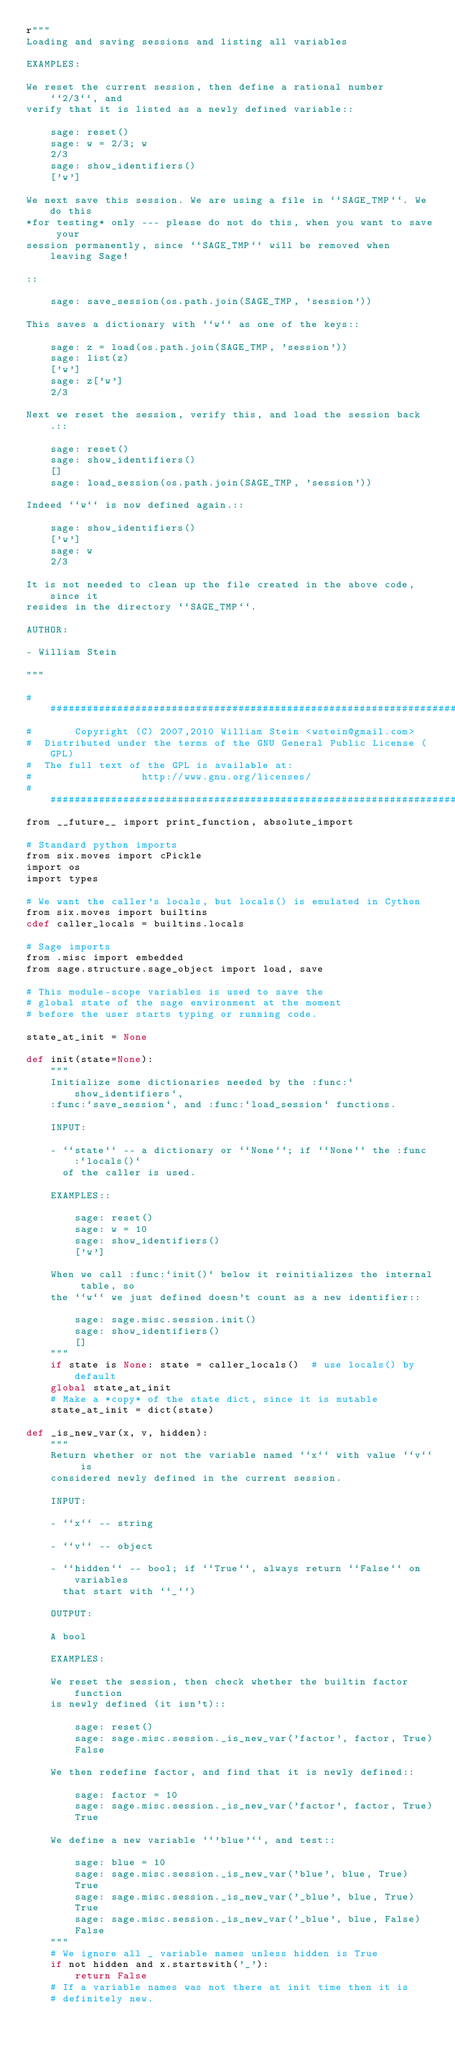Convert code to text. <code><loc_0><loc_0><loc_500><loc_500><_Cython_>r"""
Loading and saving sessions and listing all variables

EXAMPLES:

We reset the current session, then define a rational number ``2/3``, and
verify that it is listed as a newly defined variable::

    sage: reset()
    sage: w = 2/3; w
    2/3
    sage: show_identifiers()
    ['w']

We next save this session. We are using a file in ``SAGE_TMP``. We do this
*for testing* only --- please do not do this, when you want to save your
session permanently, since ``SAGE_TMP`` will be removed when leaving Sage!

::

    sage: save_session(os.path.join(SAGE_TMP, 'session'))

This saves a dictionary with ``w`` as one of the keys::

    sage: z = load(os.path.join(SAGE_TMP, 'session'))
    sage: list(z)
    ['w']
    sage: z['w']
    2/3

Next we reset the session, verify this, and load the session back.::

    sage: reset()
    sage: show_identifiers()
    []
    sage: load_session(os.path.join(SAGE_TMP, 'session'))

Indeed ``w`` is now defined again.::

    sage: show_identifiers()
    ['w']
    sage: w
    2/3

It is not needed to clean up the file created in the above code, since it
resides in the directory ``SAGE_TMP``.

AUTHOR:

- William Stein

"""

#############################################################################
#       Copyright (C) 2007,2010 William Stein <wstein@gmail.com>
#  Distributed under the terms of the GNU General Public License (GPL)
#  The full text of the GPL is available at:
#                  http://www.gnu.org/licenses/
#############################################################################
from __future__ import print_function, absolute_import

# Standard python imports
from six.moves import cPickle
import os
import types

# We want the caller's locals, but locals() is emulated in Cython
from six.moves import builtins
cdef caller_locals = builtins.locals

# Sage imports
from .misc import embedded
from sage.structure.sage_object import load, save

# This module-scope variables is used to save the
# global state of the sage environment at the moment
# before the user starts typing or running code.

state_at_init = None

def init(state=None):
    """
    Initialize some dictionaries needed by the :func:`show_identifiers`,
    :func:`save_session`, and :func:`load_session` functions.

    INPUT:

    - ``state`` -- a dictionary or ``None``; if ``None`` the :func:`locals()`
      of the caller is used.

    EXAMPLES::

        sage: reset()
        sage: w = 10
        sage: show_identifiers()
        ['w']

    When we call :func:`init()` below it reinitializes the internal table, so
    the ``w`` we just defined doesn't count as a new identifier::

        sage: sage.misc.session.init()
        sage: show_identifiers()
        []
    """
    if state is None: state = caller_locals()  # use locals() by default
    global state_at_init
    # Make a *copy* of the state dict, since it is mutable
    state_at_init = dict(state)

def _is_new_var(x, v, hidden):
    """
    Return whether or not the variable named ``x`` with value ``v`` is
    considered newly defined in the current session.

    INPUT:

    - ``x`` -- string

    - ``v`` -- object

    - ``hidden`` -- bool; if ``True``, always return ``False`` on variables
      that start with ``_``)

    OUTPUT:

    A bool

    EXAMPLES:

    We reset the session, then check whether the builtin factor function
    is newly defined (it isn't)::

        sage: reset()
        sage: sage.misc.session._is_new_var('factor', factor, True)
        False

    We then redefine factor, and find that it is newly defined::

        sage: factor = 10
        sage: sage.misc.session._is_new_var('factor', factor, True)
        True

    We define a new variable ``'blue'``, and test::

        sage: blue = 10
        sage: sage.misc.session._is_new_var('blue', blue, True)
        True
        sage: sage.misc.session._is_new_var('_blue', blue, True)
        True
        sage: sage.misc.session._is_new_var('_blue', blue, False)
        False
    """
    # We ignore all _ variable names unless hidden is True
    if not hidden and x.startswith('_'):
        return False
    # If a variable names was not there at init time then it is
    # definitely new.</code> 